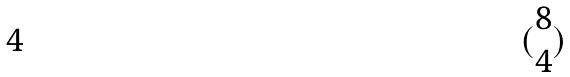Convert formula to latex. <formula><loc_0><loc_0><loc_500><loc_500>( \begin{matrix} 8 \\ 4 \end{matrix} )</formula> 